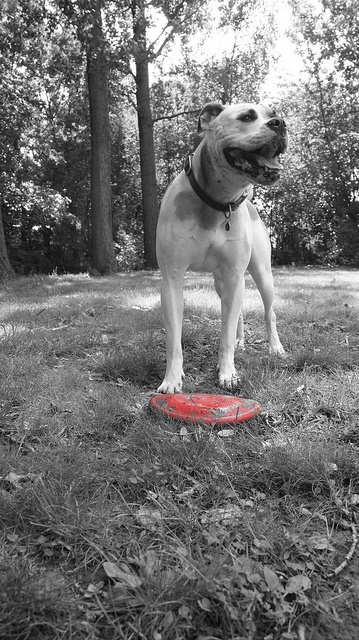Describe the objects in this image and their specific colors. I can see dog in darkgray, gray, lightgray, and black tones and frisbee in darkgray, salmon, gray, and brown tones in this image. 